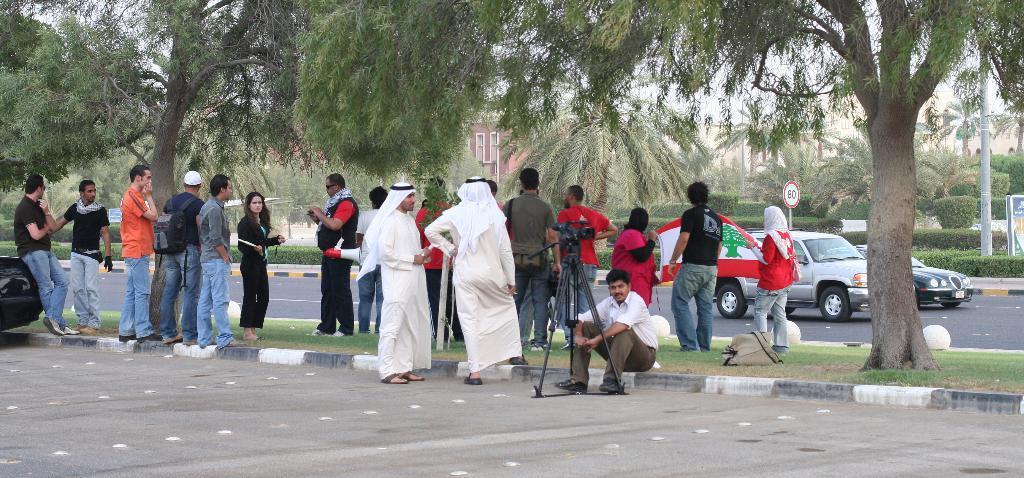Describe this image in one or two sentences. In this image there are a few people standing on the surface of the pavement and there is one person sitting on the pavement with a camera in front of him, in the background of the image there are cars passing on the road and there are trees and buildings. 